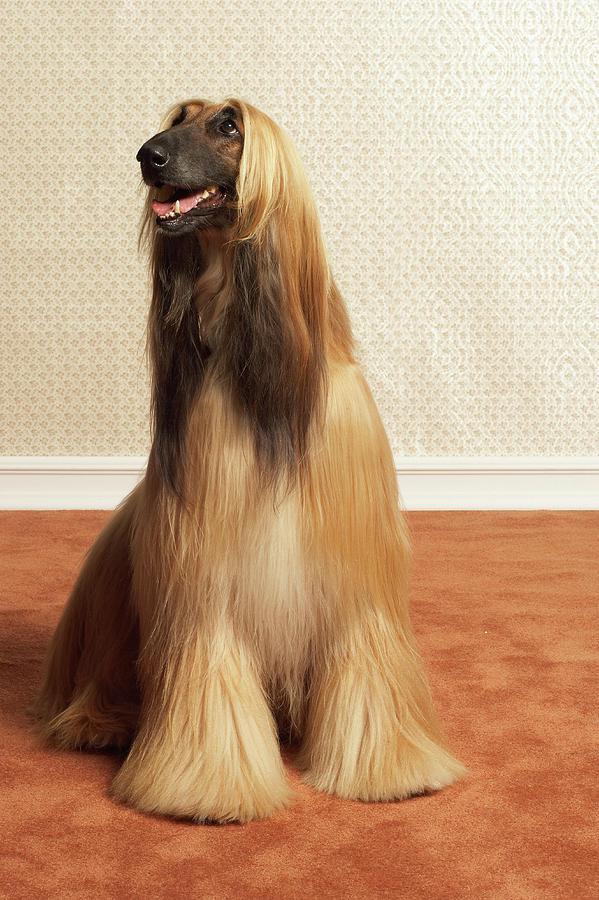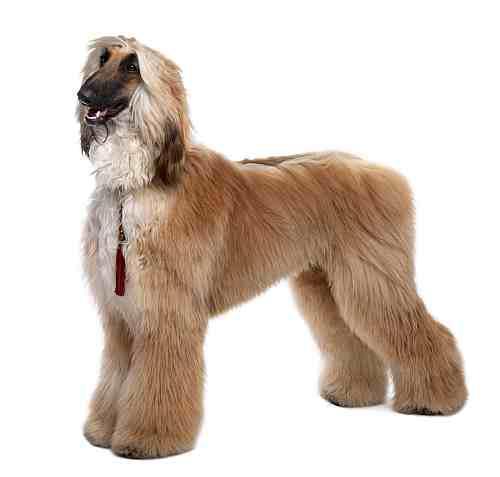The first image is the image on the left, the second image is the image on the right. Examine the images to the left and right. Is the description "Each image contains one afghan hound with light-orangish hair who is gazing to the left, and one of the depicted dogs is standing on all fours." accurate? Answer yes or no. Yes. The first image is the image on the left, the second image is the image on the right. Evaluate the accuracy of this statement regarding the images: "Both dogs' mouths are open.". Is it true? Answer yes or no. Yes. 